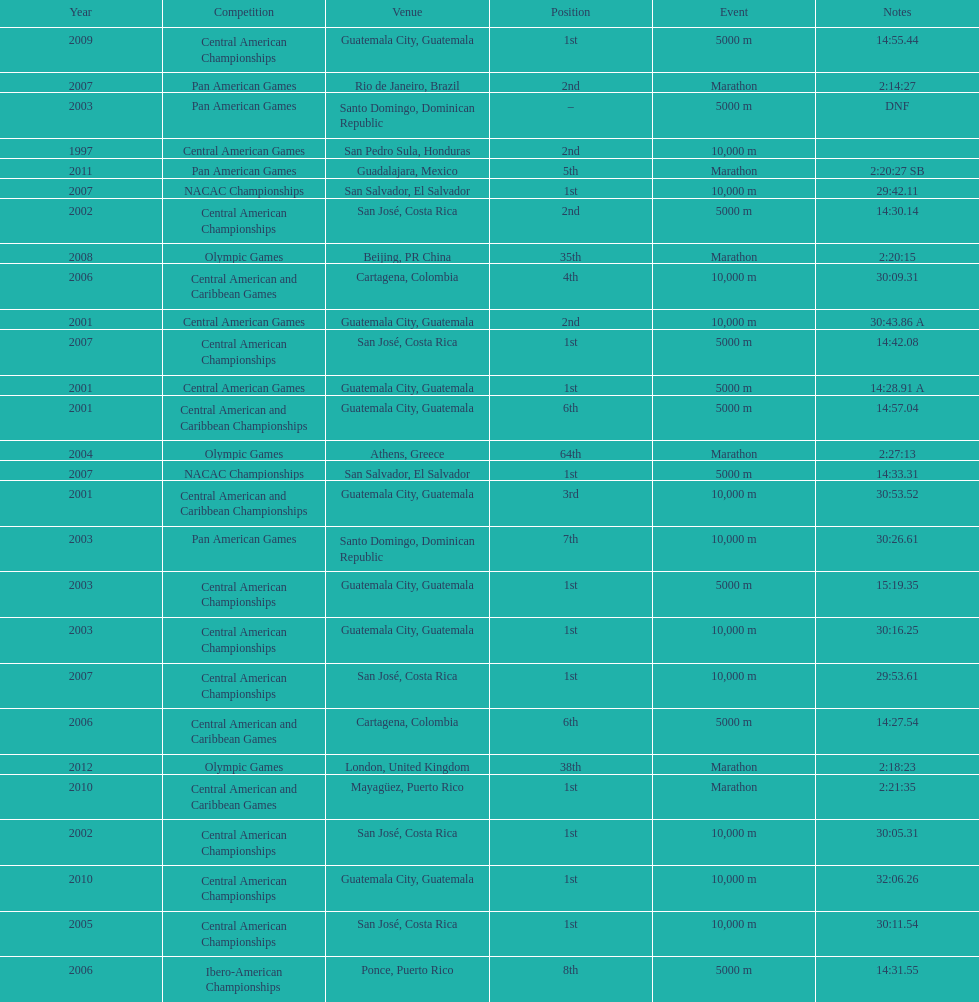Which event is listed more between the 10,000m and the 5000m? 10,000 m. 